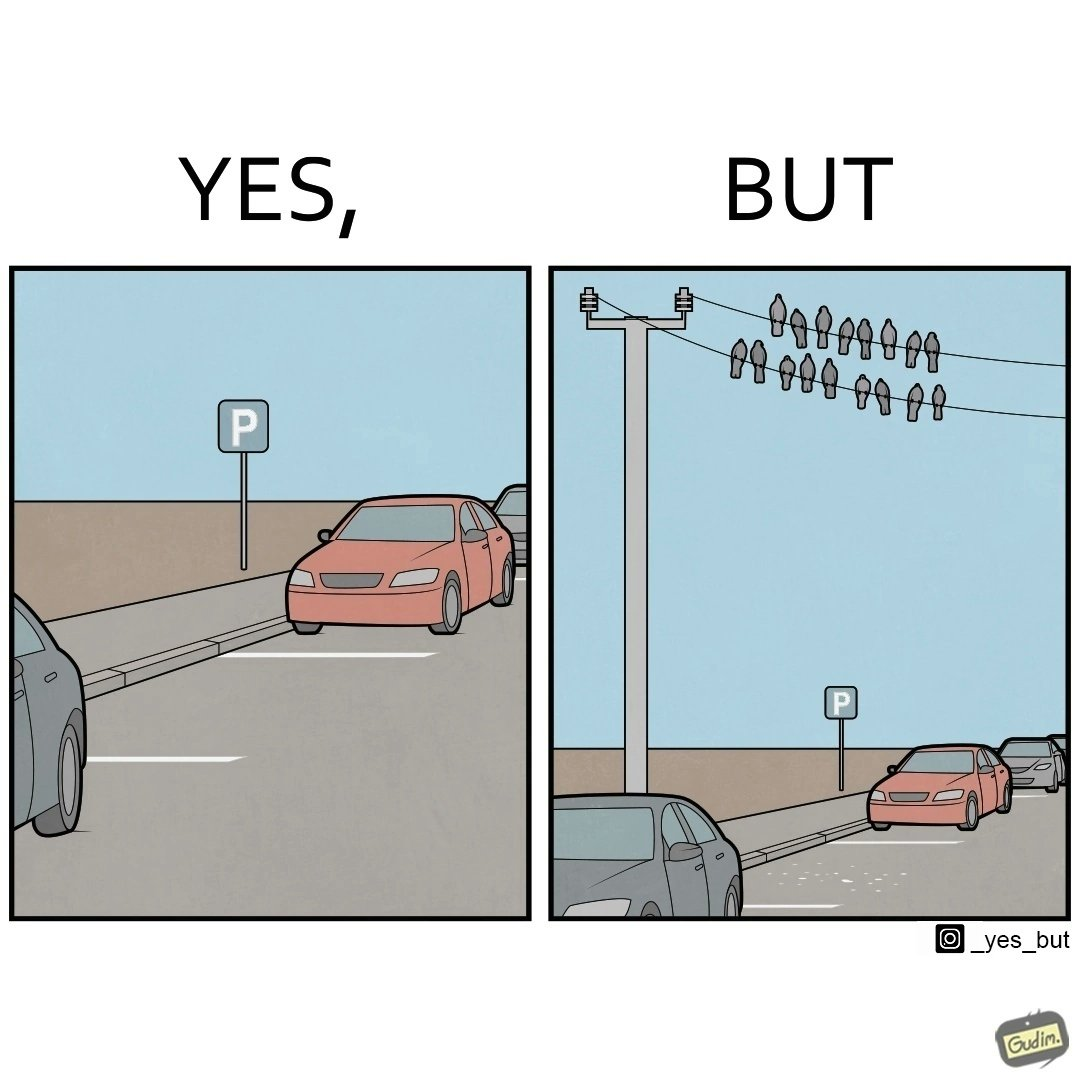Is this a satirical image? Yes, this image is satirical. 